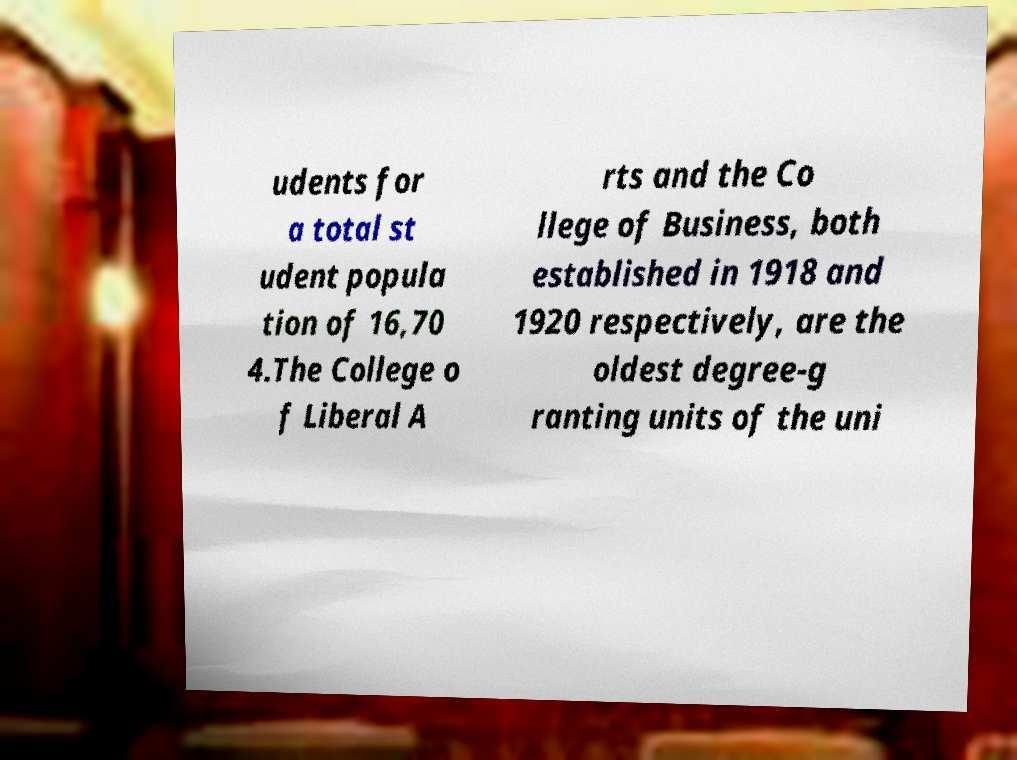Can you accurately transcribe the text from the provided image for me? udents for a total st udent popula tion of 16,70 4.The College o f Liberal A rts and the Co llege of Business, both established in 1918 and 1920 respectively, are the oldest degree-g ranting units of the uni 